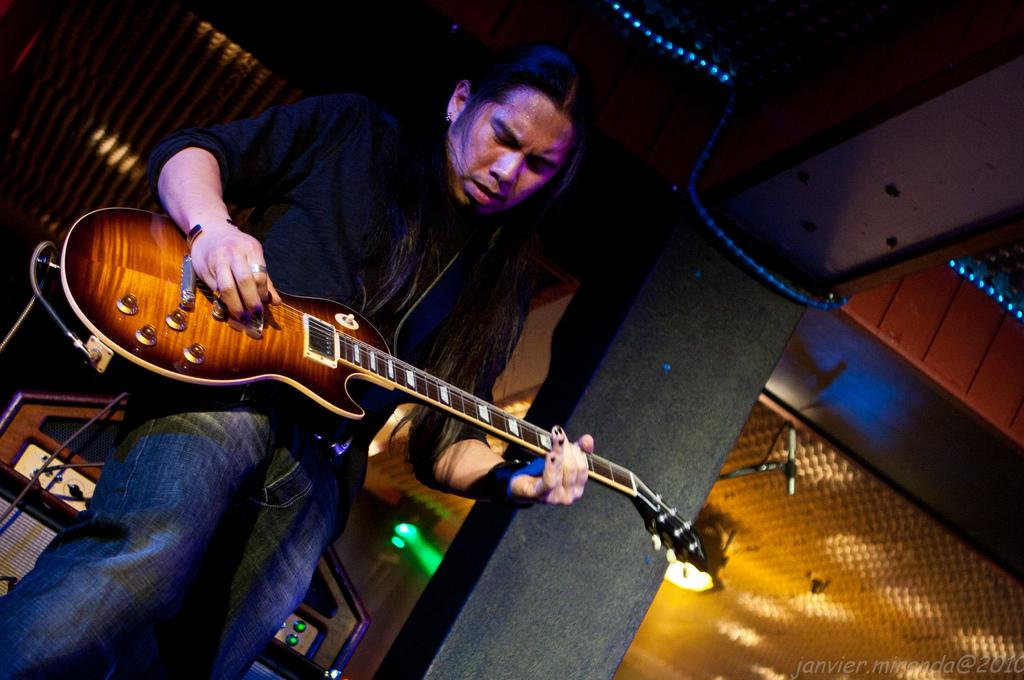What is the man in the image doing? The man is playing a guitar in the image. What can be seen behind the man? There is equipment behind the man. What is on the right side of the image? There is a pillar on the right side of the image. What type of lighting is visible in the image? Different lights are visible behind the man. What brand of toothpaste is the man using while playing the guitar in the image? There is no toothpaste present in the image, and the man is not using any toothpaste while playing the guitar. 